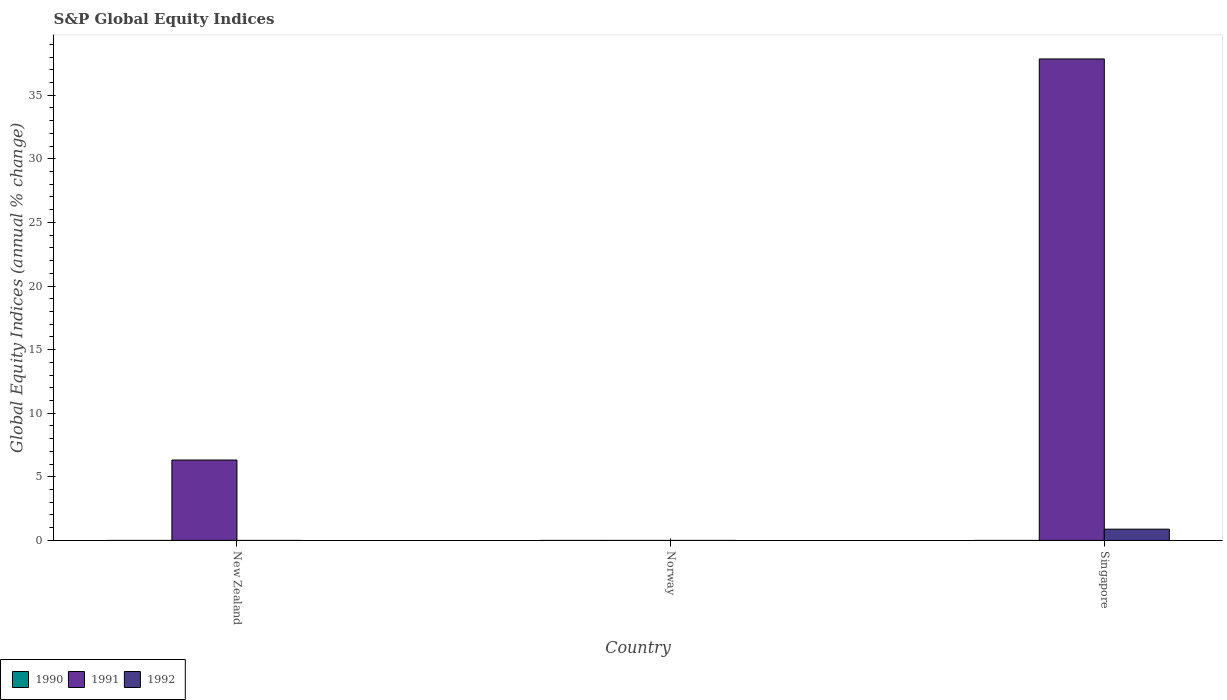How many different coloured bars are there?
Keep it short and to the point. 2. Are the number of bars on each tick of the X-axis equal?
Keep it short and to the point. No. What is the label of the 2nd group of bars from the left?
Make the answer very short. Norway. Across all countries, what is the maximum global equity indices in 1992?
Make the answer very short. 0.88. Across all countries, what is the minimum global equity indices in 1990?
Provide a short and direct response. 0. In which country was the global equity indices in 1992 maximum?
Your response must be concise. Singapore. What is the total global equity indices in 1991 in the graph?
Ensure brevity in your answer.  44.17. What is the difference between the global equity indices in 1992 in Singapore and the global equity indices in 1990 in Norway?
Make the answer very short. 0.88. In how many countries, is the global equity indices in 1992 greater than 11 %?
Your response must be concise. 0. What is the ratio of the global equity indices in 1991 in New Zealand to that in Singapore?
Your response must be concise. 0.17. What is the difference between the highest and the lowest global equity indices in 1992?
Offer a terse response. 0.88. In how many countries, is the global equity indices in 1991 greater than the average global equity indices in 1991 taken over all countries?
Ensure brevity in your answer.  1. Is the sum of the global equity indices in 1991 in New Zealand and Singapore greater than the maximum global equity indices in 1992 across all countries?
Provide a succinct answer. Yes. How many bars are there?
Ensure brevity in your answer.  3. Are the values on the major ticks of Y-axis written in scientific E-notation?
Provide a short and direct response. No. Does the graph contain any zero values?
Make the answer very short. Yes. Does the graph contain grids?
Your answer should be compact. No. How are the legend labels stacked?
Keep it short and to the point. Horizontal. What is the title of the graph?
Keep it short and to the point. S&P Global Equity Indices. Does "2006" appear as one of the legend labels in the graph?
Provide a succinct answer. No. What is the label or title of the X-axis?
Your answer should be very brief. Country. What is the label or title of the Y-axis?
Make the answer very short. Global Equity Indices (annual % change). What is the Global Equity Indices (annual % change) of 1990 in New Zealand?
Provide a succinct answer. 0. What is the Global Equity Indices (annual % change) of 1991 in New Zealand?
Your response must be concise. 6.32. What is the Global Equity Indices (annual % change) in 1992 in New Zealand?
Offer a terse response. 0. What is the Global Equity Indices (annual % change) of 1992 in Norway?
Make the answer very short. 0. What is the Global Equity Indices (annual % change) of 1990 in Singapore?
Offer a very short reply. 0. What is the Global Equity Indices (annual % change) of 1991 in Singapore?
Provide a succinct answer. 37.85. What is the Global Equity Indices (annual % change) of 1992 in Singapore?
Your response must be concise. 0.88. Across all countries, what is the maximum Global Equity Indices (annual % change) of 1991?
Your answer should be very brief. 37.85. Across all countries, what is the maximum Global Equity Indices (annual % change) in 1992?
Your answer should be compact. 0.88. Across all countries, what is the minimum Global Equity Indices (annual % change) of 1991?
Make the answer very short. 0. Across all countries, what is the minimum Global Equity Indices (annual % change) of 1992?
Your answer should be very brief. 0. What is the total Global Equity Indices (annual % change) in 1991 in the graph?
Give a very brief answer. 44.17. What is the total Global Equity Indices (annual % change) in 1992 in the graph?
Offer a terse response. 0.88. What is the difference between the Global Equity Indices (annual % change) of 1991 in New Zealand and that in Singapore?
Your response must be concise. -31.53. What is the difference between the Global Equity Indices (annual % change) of 1991 in New Zealand and the Global Equity Indices (annual % change) of 1992 in Singapore?
Make the answer very short. 5.44. What is the average Global Equity Indices (annual % change) of 1991 per country?
Your answer should be very brief. 14.72. What is the average Global Equity Indices (annual % change) in 1992 per country?
Provide a succinct answer. 0.29. What is the difference between the Global Equity Indices (annual % change) of 1991 and Global Equity Indices (annual % change) of 1992 in Singapore?
Give a very brief answer. 36.97. What is the ratio of the Global Equity Indices (annual % change) in 1991 in New Zealand to that in Singapore?
Your response must be concise. 0.17. What is the difference between the highest and the lowest Global Equity Indices (annual % change) of 1991?
Your answer should be compact. 37.85. What is the difference between the highest and the lowest Global Equity Indices (annual % change) of 1992?
Your answer should be compact. 0.88. 